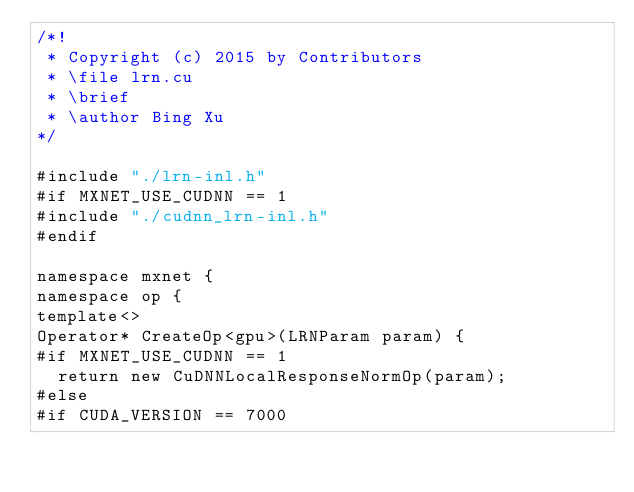Convert code to text. <code><loc_0><loc_0><loc_500><loc_500><_Cuda_>/*!
 * Copyright (c) 2015 by Contributors
 * \file lrn.cu
 * \brief
 * \author Bing Xu
*/

#include "./lrn-inl.h"
#if MXNET_USE_CUDNN == 1
#include "./cudnn_lrn-inl.h"
#endif

namespace mxnet {
namespace op {
template<>
Operator* CreateOp<gpu>(LRNParam param) {
#if MXNET_USE_CUDNN == 1
  return new CuDNNLocalResponseNormOp(param);
#else
#if CUDA_VERSION == 7000</code> 